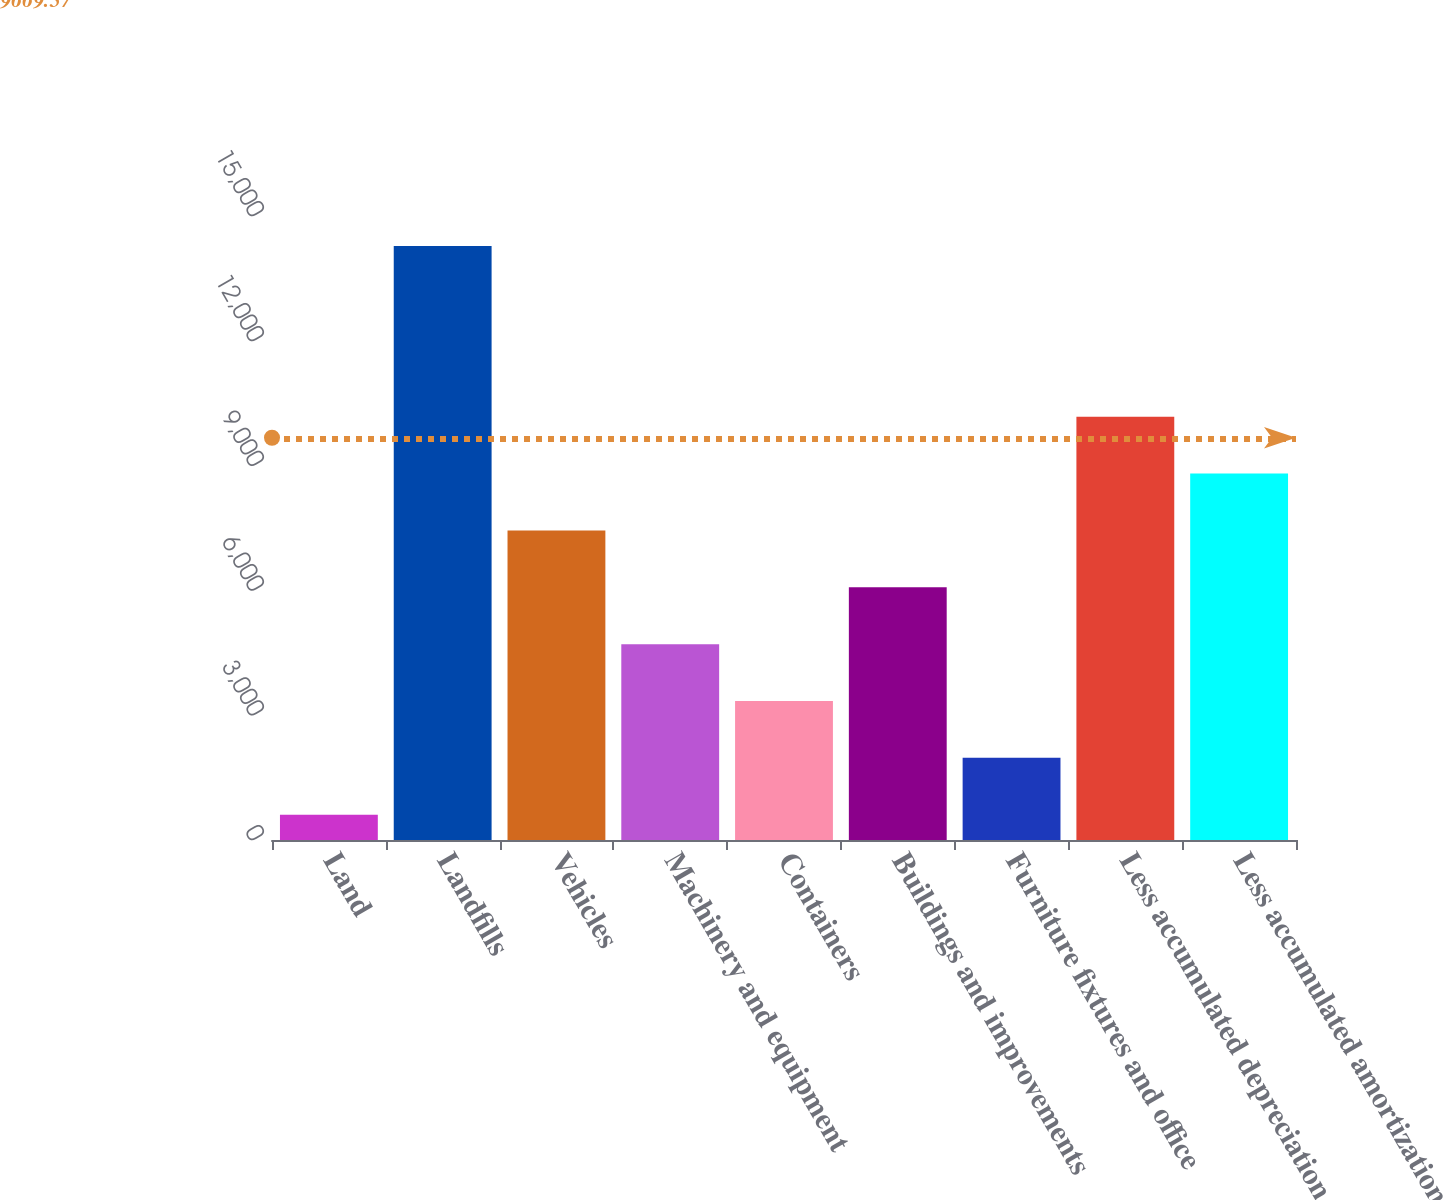Convert chart to OTSL. <chart><loc_0><loc_0><loc_500><loc_500><bar_chart><fcel>Land<fcel>Landfills<fcel>Vehicles<fcel>Machinery and equipment<fcel>Containers<fcel>Buildings and improvements<fcel>Furniture fixtures and office<fcel>Less accumulated depreciation<fcel>Less accumulated amortization<nl><fcel>608<fcel>14276<fcel>7442<fcel>4708.4<fcel>3341.6<fcel>6075.2<fcel>1974.8<fcel>10175.6<fcel>8808.8<nl></chart> 